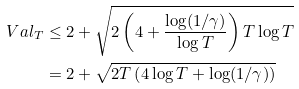<formula> <loc_0><loc_0><loc_500><loc_500>\ V a l _ { T } & \leq 2 + \sqrt { 2 \left ( 4 + \frac { \log ( 1 / \gamma ) } { \log T } \right ) T \log T } \\ & = 2 + \sqrt { 2 T \left ( 4 \log T + \log ( 1 / \gamma ) \right ) }</formula> 